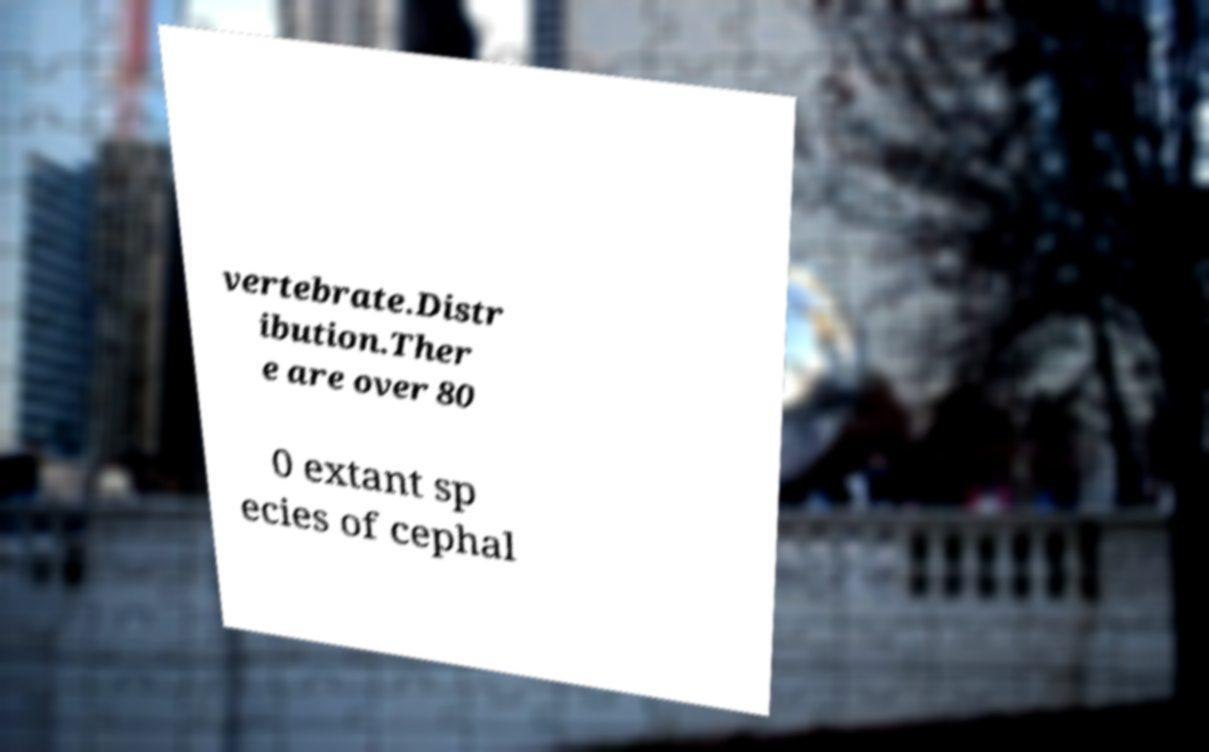What messages or text are displayed in this image? I need them in a readable, typed format. vertebrate.Distr ibution.Ther e are over 80 0 extant sp ecies of cephal 